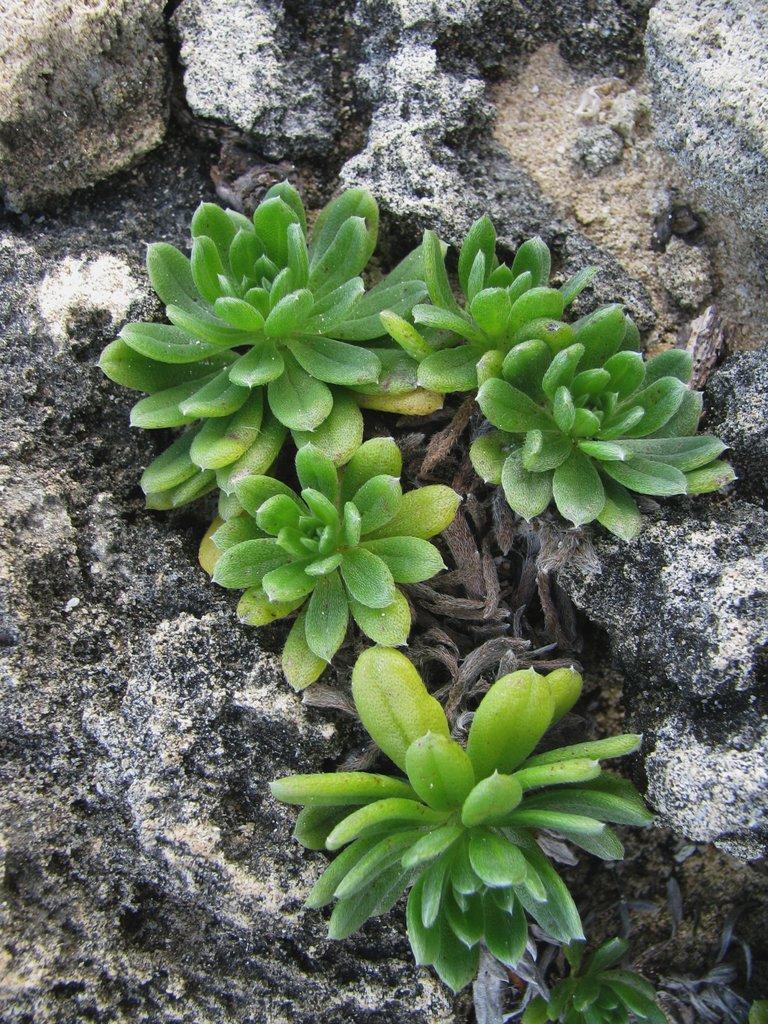Can you describe this image briefly? In this picture there are plants and there are rocks. 